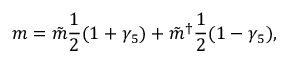<formula> <loc_0><loc_0><loc_500><loc_500>m = \tilde { m } \frac { 1 } { 2 } ( 1 + \gamma _ { 5 } ) + \tilde { m } ^ { \dagger } \frac { 1 } { 2 } ( 1 - \gamma _ { 5 } ) ,</formula> 